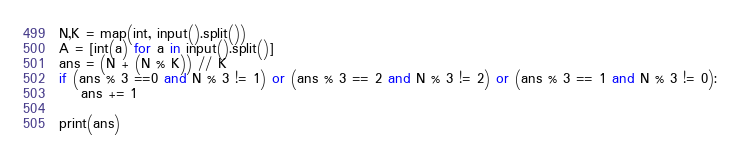Convert code to text. <code><loc_0><loc_0><loc_500><loc_500><_Python_>N,K = map(int, input().split())
A = [int(a) for a in input().split()]
ans = (N + (N % K)) // K
if (ans % 3 ==0 and N % 3 != 1) or (ans % 3 == 2 and N % 3 != 2) or (ans % 3 == 1 and N % 3 != 0):
    ans += 1
    
print(ans)</code> 